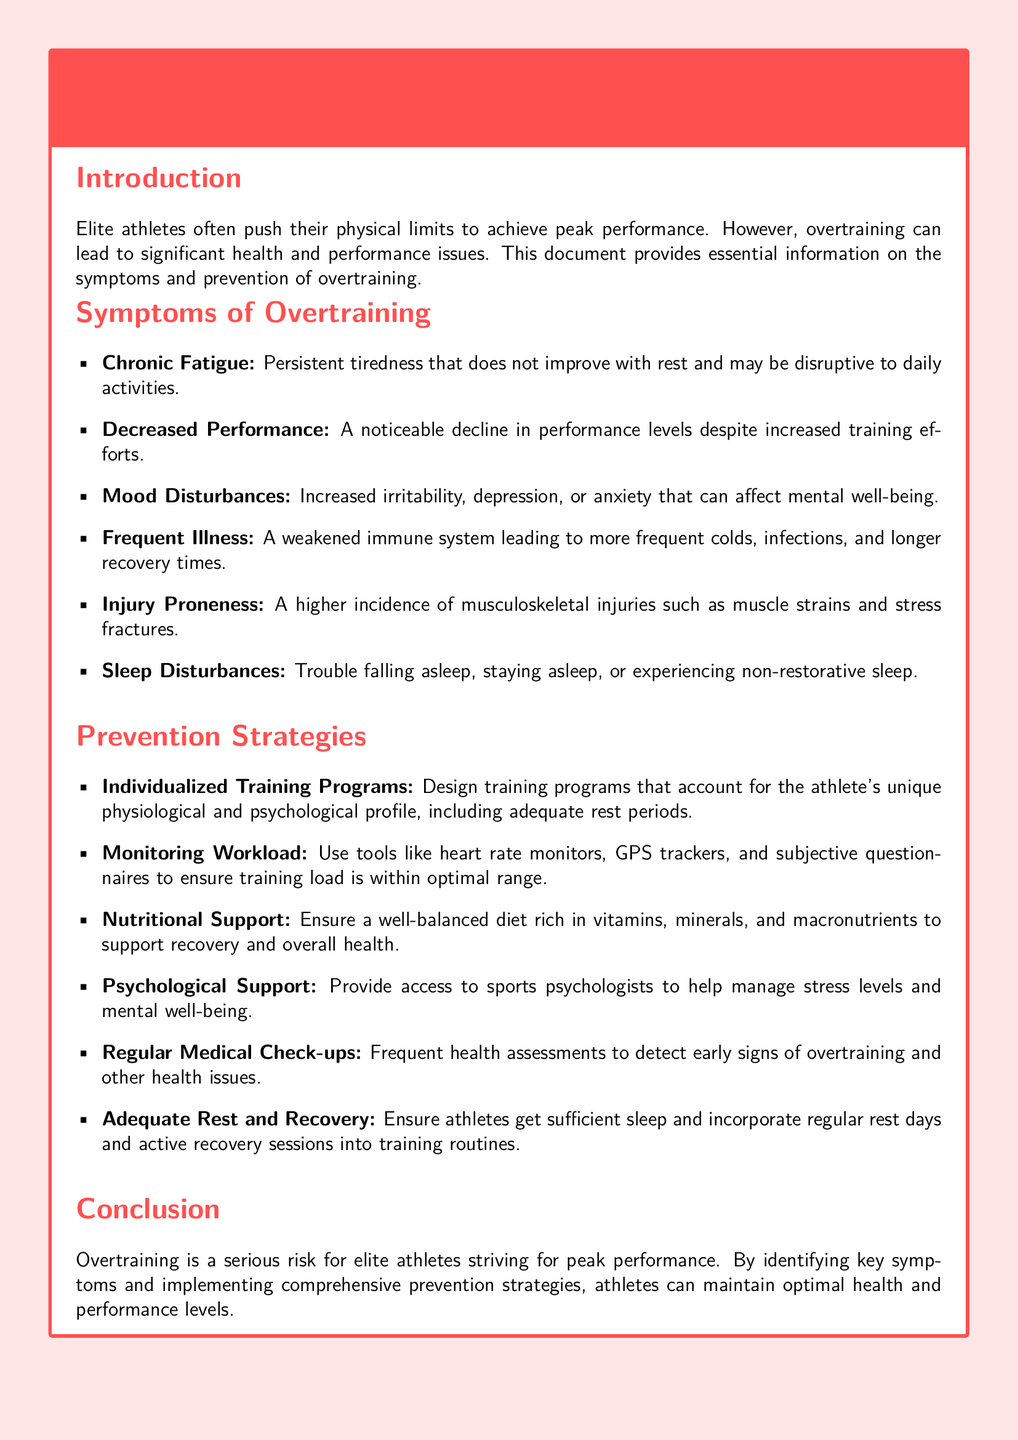What is the title of the document? The title is clearly stated at the beginning of the document in the title box.
Answer: Warning: Potential Risks of Overtraining for Elite Athletes How many symptoms of overtraining are listed? The document provides a bullet list of symptoms, which can be counted.
Answer: Six What is one example of a mood disturbance caused by overtraining? The document specifies mood disturbances among the symptoms.
Answer: Irritability What type of support is mentioned for psychological help? The document mentions a specific type of professional support provided to athletes.
Answer: Sports psychologists What is a key strategy for preventing overtraining? The document outlines specific strategies and examples for prevention.
Answer: Individualized Training Programs What symptom indicates a decline in athletic performance? The document identifies a particular symptom that refers to performance decline.
Answer: Decreased Performance What aspect of health should be monitored regularly? The document emphasizes health assessments to catch potential issues early on.
Answer: Medical Check-ups What type of nutritional support is recommended? The document refers to the overall quality and content of the athlete's diet.
Answer: Well-balanced diet 